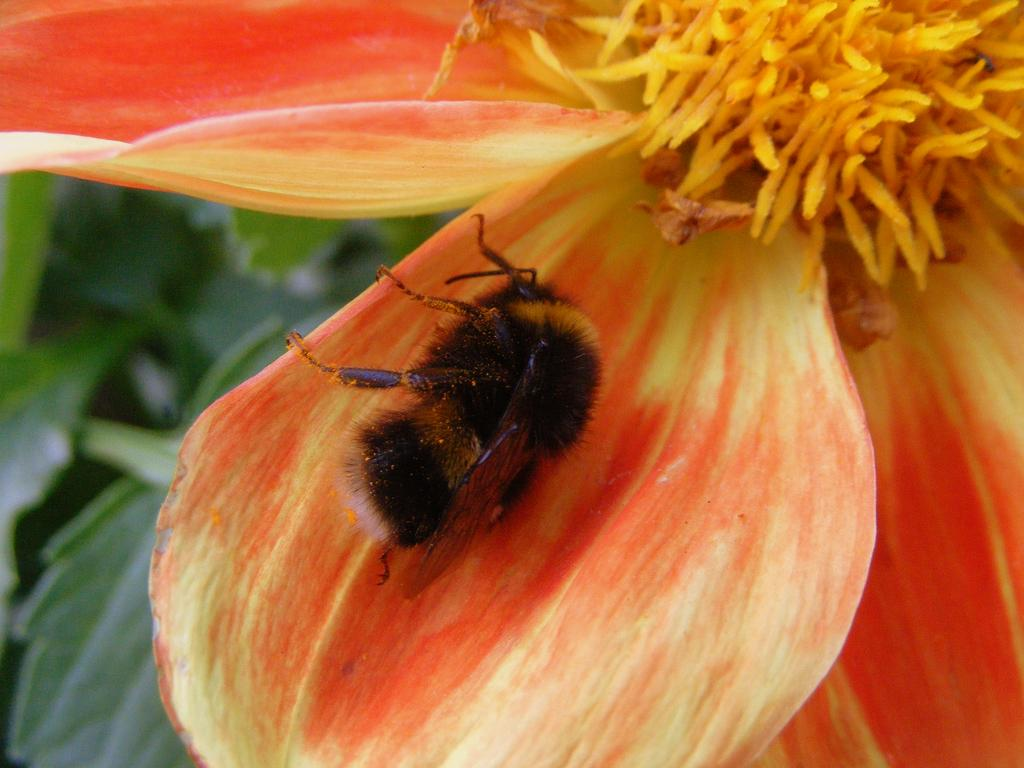What is the main subject in the foreground of the image? There is a flower in the foreground of the image. Is there anything interacting with the flower? Yes, there is an insect on the flower. What can be seen on the left side of the image? There are leaves visible on the left side of the image. What type of crayon is being used to color the leaves in the image? There is no crayon present in the image; it is a photograph of a flower and leaves. What stage of development is the flower in the image? The stage of development of the flower cannot be determined from the image alone. 